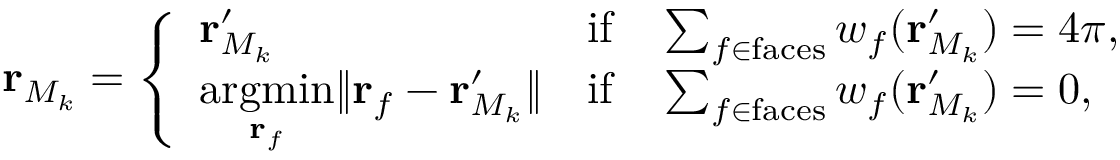Convert formula to latex. <formula><loc_0><loc_0><loc_500><loc_500>r _ { M _ { k } } = \left \{ \begin{array} { l l } { r _ { M _ { k } } ^ { \prime } } & { i f \quad \sum _ { f \in f a c e s } w _ { f } ( r _ { M _ { k } } ^ { \prime } ) = 4 \pi , } \\ { \underset { r _ { f } } { \arg \min } \| r _ { f } - r _ { M _ { k } } ^ { \prime } \| } & { i f \quad \sum _ { f \in f a c e s } w _ { f } ( r _ { M _ { k } } ^ { \prime } ) = 0 , } \end{array}</formula> 